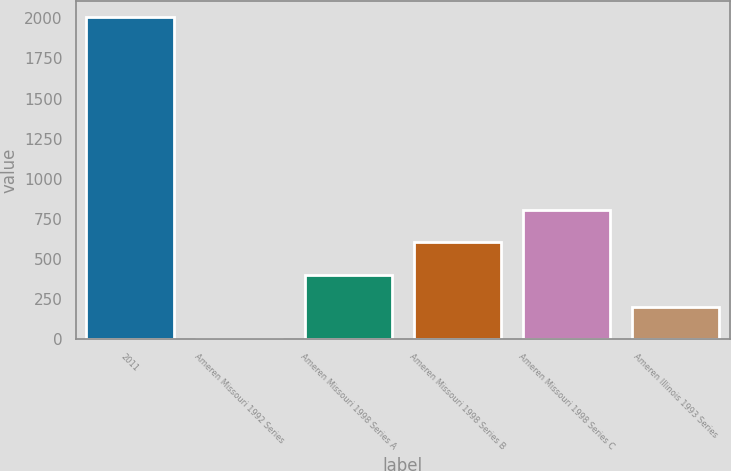Convert chart to OTSL. <chart><loc_0><loc_0><loc_500><loc_500><bar_chart><fcel>2011<fcel>Ameren Missouri 1992 Series<fcel>Ameren Missouri 1998 Series A<fcel>Ameren Missouri 1998 Series B<fcel>Ameren Missouri 1998 Series C<fcel>Ameren Illinois 1993 Series<nl><fcel>2010<fcel>0.47<fcel>402.37<fcel>603.32<fcel>804.27<fcel>201.42<nl></chart> 